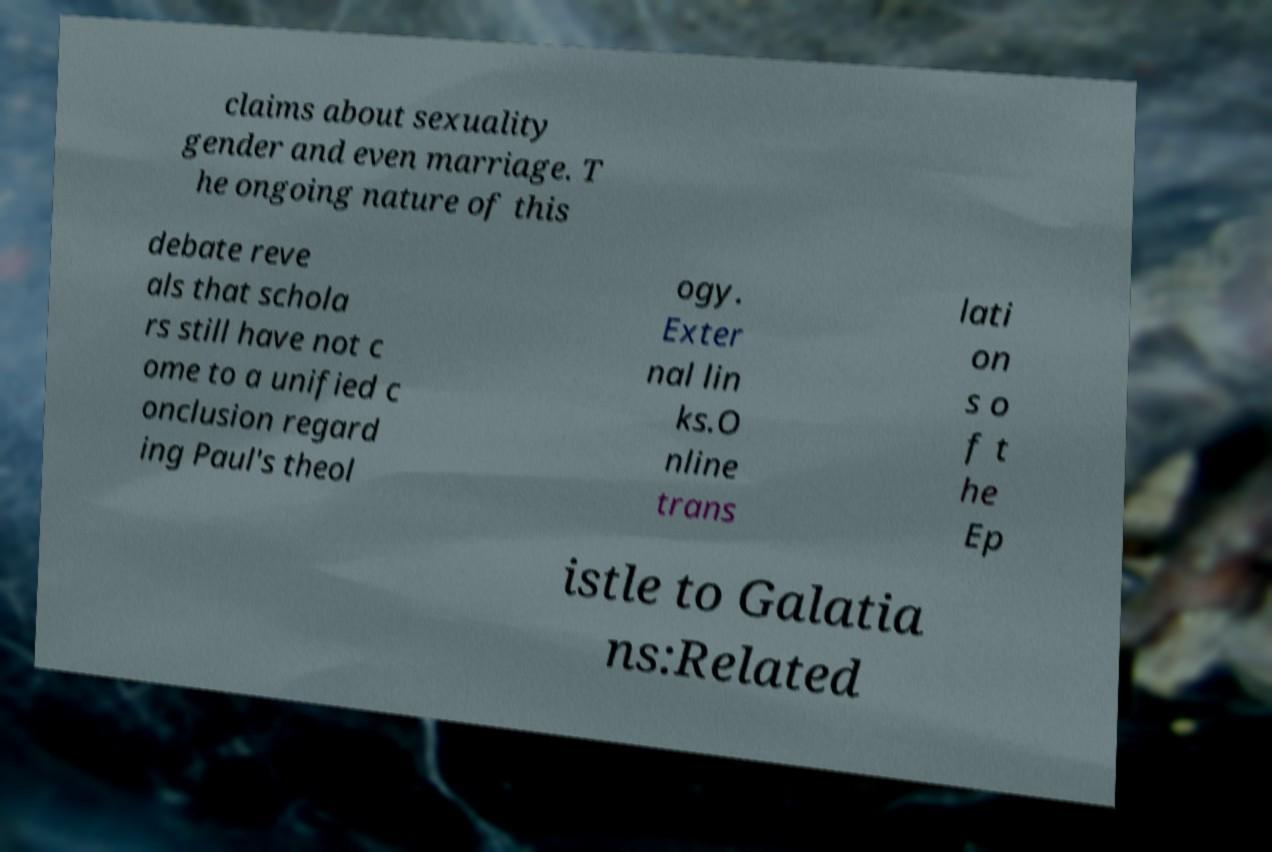Can you accurately transcribe the text from the provided image for me? claims about sexuality gender and even marriage. T he ongoing nature of this debate reve als that schola rs still have not c ome to a unified c onclusion regard ing Paul's theol ogy. Exter nal lin ks.O nline trans lati on s o f t he Ep istle to Galatia ns:Related 